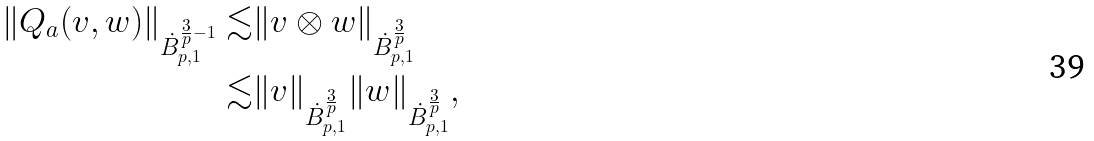<formula> <loc_0><loc_0><loc_500><loc_500>\| Q _ { a } ( v , w ) \| _ { \dot { B } ^ { \frac { 3 } { p } - 1 } _ { p , 1 } } \lesssim & \| v \otimes w \| _ { \dot { B } ^ { \frac { 3 } { p } } _ { p , 1 } } \\ \lesssim & \| v \| _ { \dot { B } ^ { \frac { 3 } { p } } _ { p , 1 } } \| w \| _ { \dot { B } ^ { \frac { 3 } { p } } _ { p , 1 } } ,</formula> 